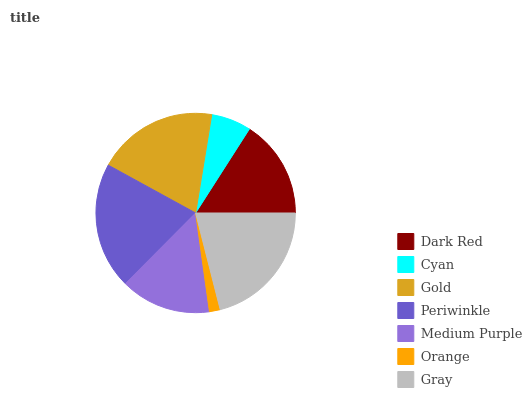Is Orange the minimum?
Answer yes or no. Yes. Is Gray the maximum?
Answer yes or no. Yes. Is Cyan the minimum?
Answer yes or no. No. Is Cyan the maximum?
Answer yes or no. No. Is Dark Red greater than Cyan?
Answer yes or no. Yes. Is Cyan less than Dark Red?
Answer yes or no. Yes. Is Cyan greater than Dark Red?
Answer yes or no. No. Is Dark Red less than Cyan?
Answer yes or no. No. Is Dark Red the high median?
Answer yes or no. Yes. Is Dark Red the low median?
Answer yes or no. Yes. Is Gray the high median?
Answer yes or no. No. Is Orange the low median?
Answer yes or no. No. 